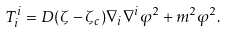Convert formula to latex. <formula><loc_0><loc_0><loc_500><loc_500>T _ { i } ^ { i } = D ( \zeta - \zeta _ { c } ) \nabla _ { i } \nabla ^ { i } \varphi ^ { 2 } + m ^ { 2 } \varphi ^ { 2 } .</formula> 